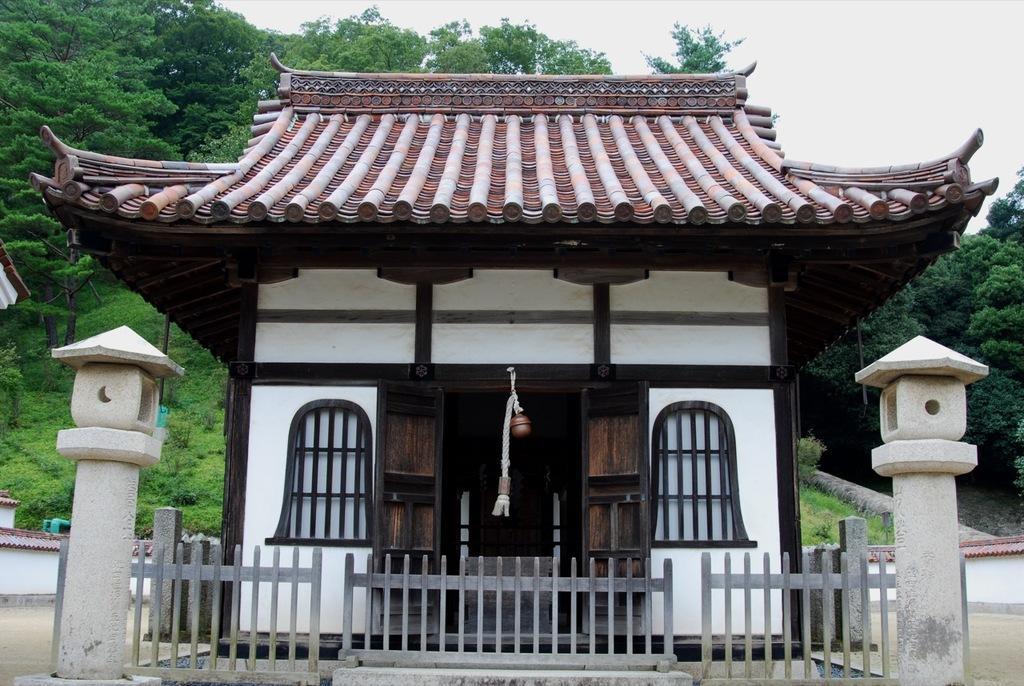How would you summarize this image in a sentence or two? In this image there is a big building in front of that there is a fence in between the pillars and behind the building there is a mountain with trees and grass. 